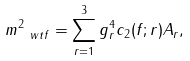Convert formula to latex. <formula><loc_0><loc_0><loc_500><loc_500>m _ { \ w t { f } } ^ { 2 } = \sum _ { r = 1 } ^ { 3 } g _ { r } ^ { 4 } c _ { 2 } ( f ; r ) A _ { r } ,</formula> 